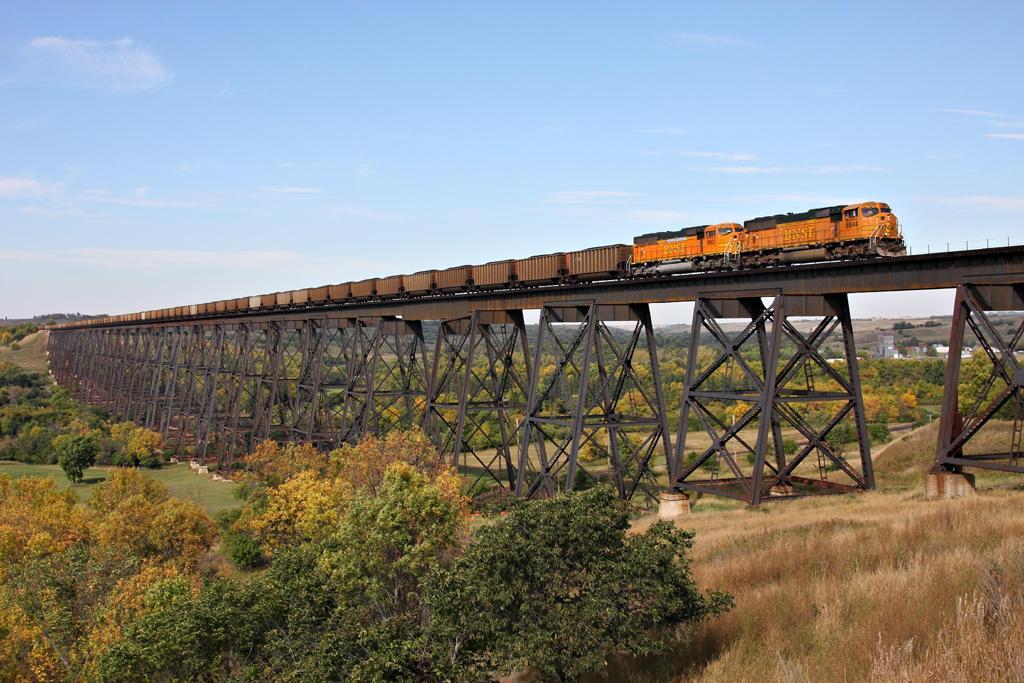Could you give a brief overview of what you see in this image? In this picture I can see the goods train. I can see the bridge. I can see trees. I can see clouds in the sky. 